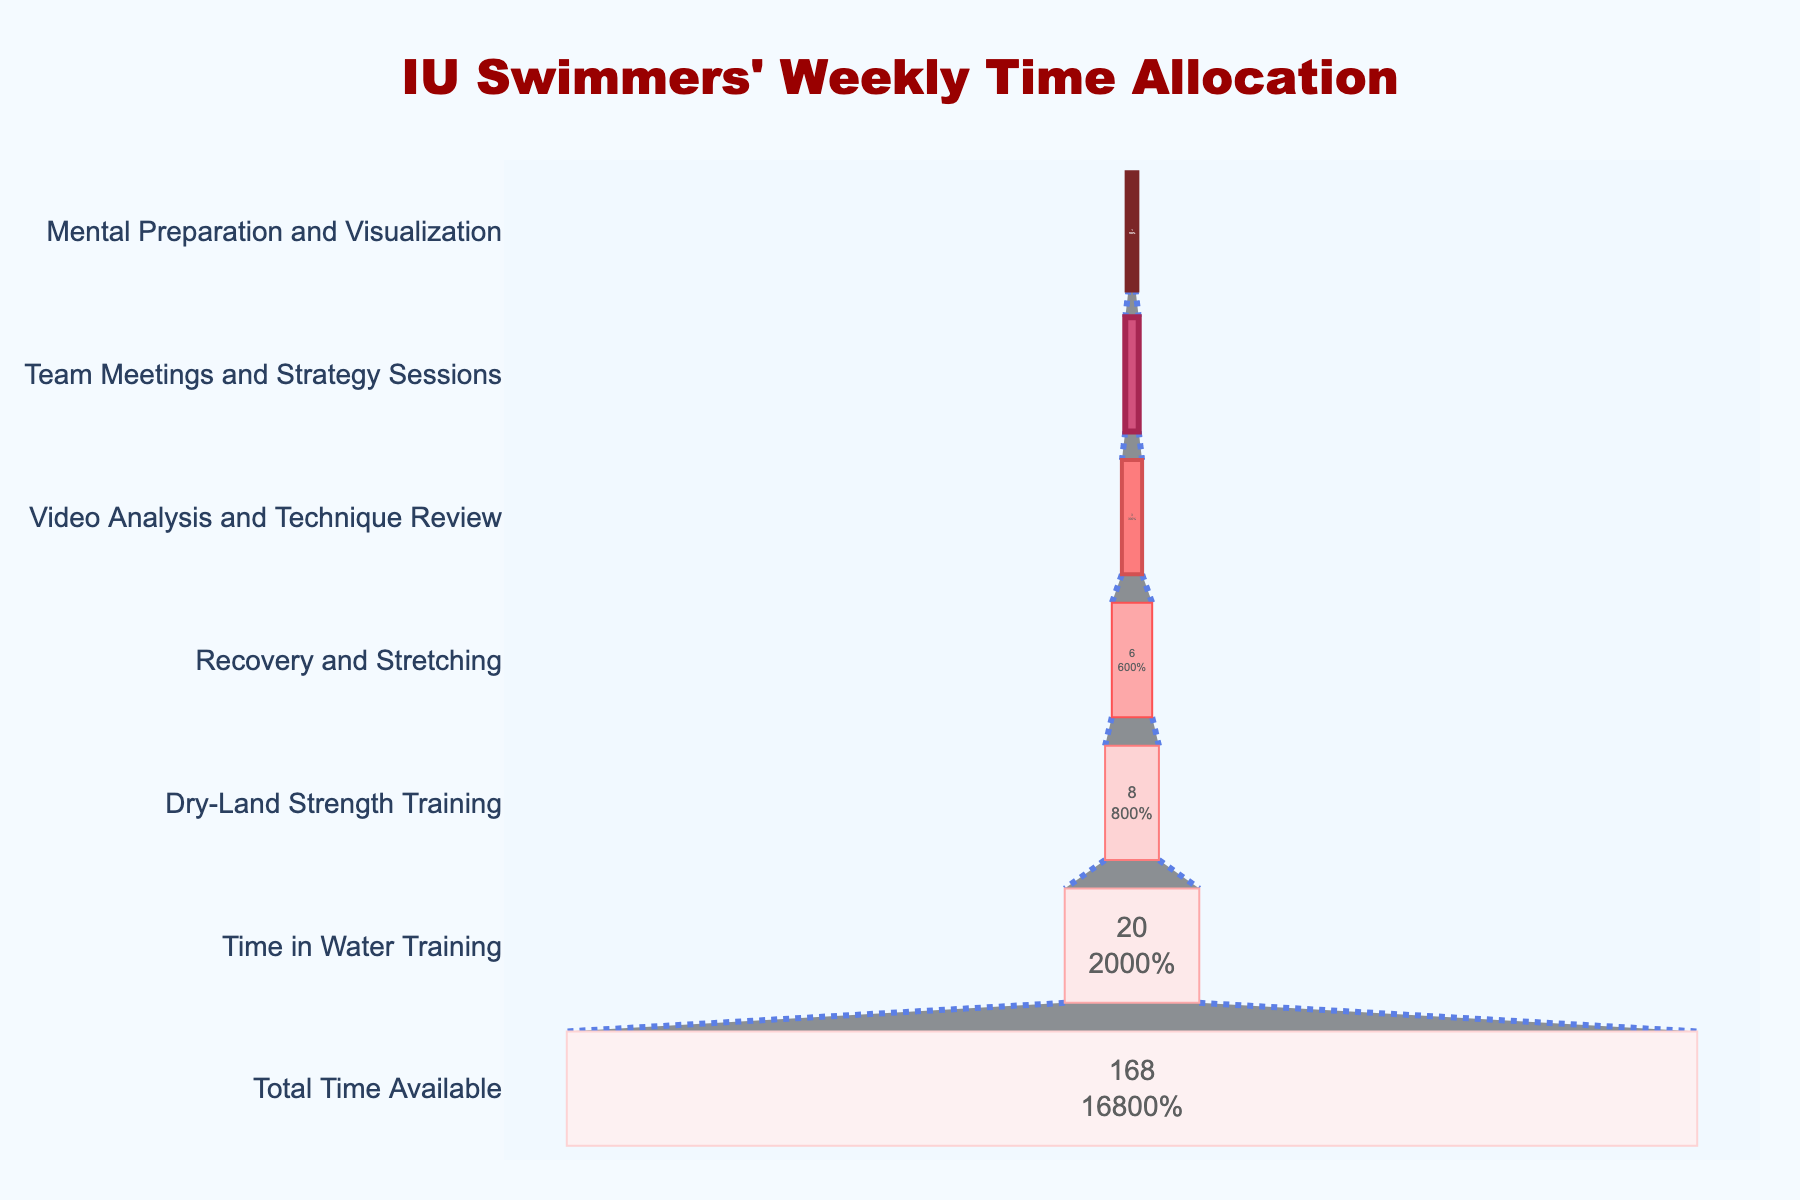What is the title of the funnel chart? The title of the funnel chart is typically displayed at the top center of the chart. It reads "IU Swimmers' Weekly Time Allocation".
Answer: IU Swimmers' Weekly Time Allocation Which activity do IU swimmers spend the most hours on during a typical week? The funnel chart shows "Total Time Available" and then breaks it down by various activities. The activity with the highest number of hours after the total is "Time in Water Training".
Answer: Time in Water Training How many hours per week do swimmers spend on Mental Preparation and Visualization? According to the funnel chart, the "Mental Preparation and Visualization" activity has a specific number of hours indicated inside the funnel slice.
Answer: 1 hour How many more hours are spent in Water Training compared to Team Meetings and Strategy Sessions? To determine this, compare the hours for "Time in Water Training" and "Team Meetings and Strategy Sessions". Subtract the hours of the latter from the former (20 - 2).
Answer: 18 hours What percentage of the initial total time is spent on Dry-Land Strength Training? The funnel chart shows the percentage along with the number of hours for each activity. The percentage for "Dry-Land Strength Training" relative to the initial total time (168 hours) is indicated on the chart.
Answer: 4.76% Which activities are allocated fewer than 5 hours per week? By examining the hours detailed inside each funnel section, we see that "Video Analysis and Technique Review", "Team Meetings and Strategy Sessions", and "Mental Preparation and Visualization" are all less than 5 hours per week.
Answer: Video Analysis and Technique Review, Team Meetings and Strategy Sessions, and Mental Preparation and Visualization What is the total number of hours spent on training-related activities excluding recovery and meetings? Sum the hours for "Time in Water Training", "Dry-Land Strength Training", and "Video Analysis and Technique Review" (20 + 8 + 3).
Answer: 31 hours Which activity has the smallest slice width in the funnel chart? The activity with the smallest slice width in the funnel chart is the activity with the lowest number of hours, which is "Mental Preparation and Visualization".
Answer: Mental Preparation and Visualization How many hours are left after all the listed activities are completed in a week? Sum all the hours spent on each activity (20 + 8 + 6 + 3 + 2 + 1) and subtract from the total time available (168 - 40).
Answer: 128 hours 